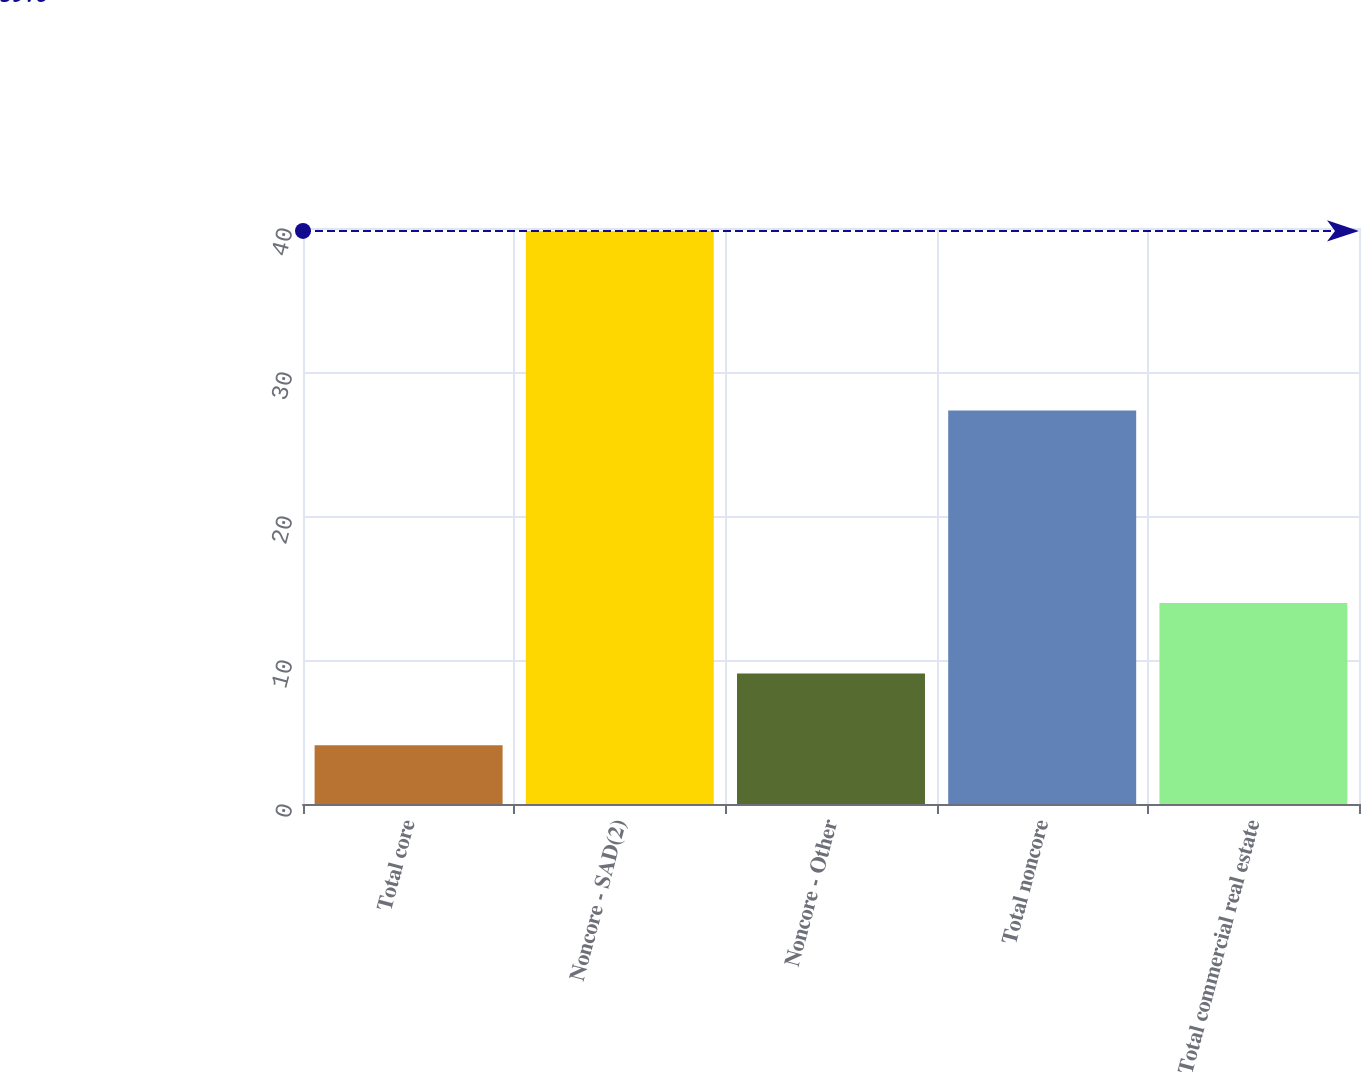<chart> <loc_0><loc_0><loc_500><loc_500><bar_chart><fcel>Total core<fcel>Noncore - SAD(2)<fcel>Noncore - Other<fcel>Total noncore<fcel>Total commercial real estate<nl><fcel>4.08<fcel>39.8<fcel>9.06<fcel>27.33<fcel>13.96<nl></chart> 